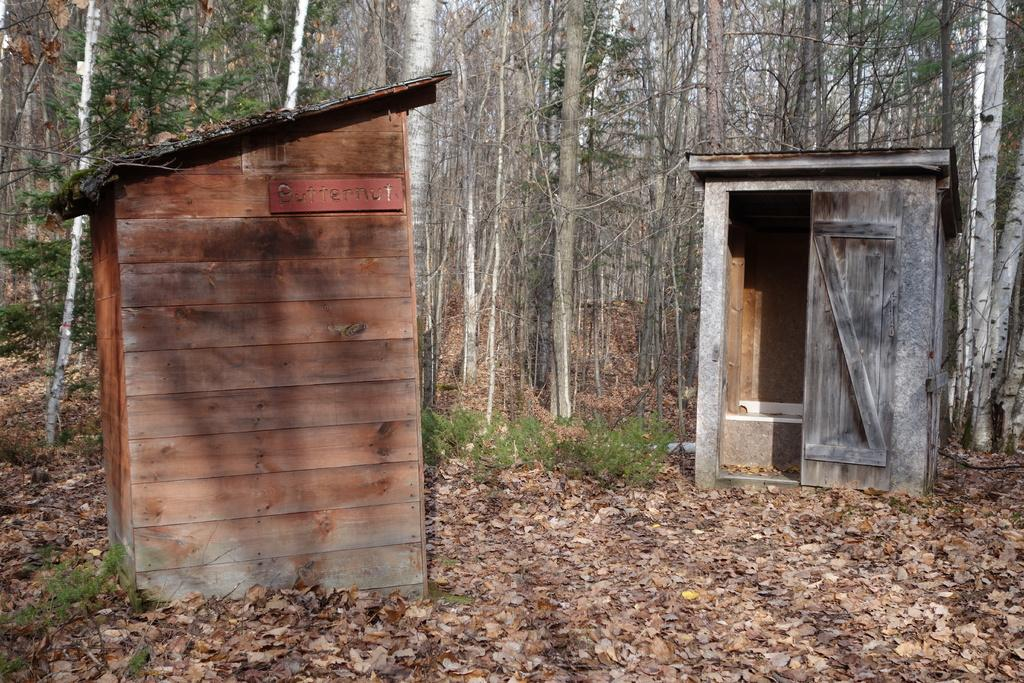What type of structures can be seen in the image? There are wooden sheds in the image. What is covering the ground in the image? Shredded leaves are present on the ground. What type of vegetation is visible in the image? Shrubs and trees are visible in the image. What part of the natural environment is visible in the image? The sky is visible in the image. How many boats are docked near the wooden sheds in the image? There are no boats present in the image; it features wooden sheds, shredded leaves, shrubs, trees, and the sky. What type of support is the cow leaning on in the image? There is no cow present in the image, so it is not possible to determine what type of support it might be leaning on. 